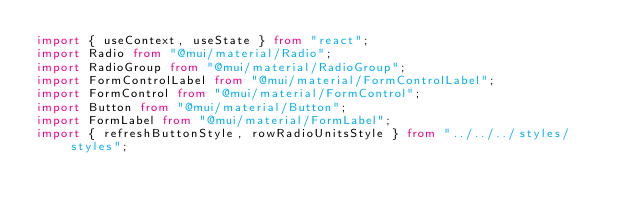<code> <loc_0><loc_0><loc_500><loc_500><_TypeScript_>import { useContext, useState } from "react";
import Radio from "@mui/material/Radio";
import RadioGroup from "@mui/material/RadioGroup";
import FormControlLabel from "@mui/material/FormControlLabel";
import FormControl from "@mui/material/FormControl";
import Button from "@mui/material/Button";
import FormLabel from "@mui/material/FormLabel";
import { refreshButtonStyle, rowRadioUnitsStyle } from "../../../styles/styles";</code> 